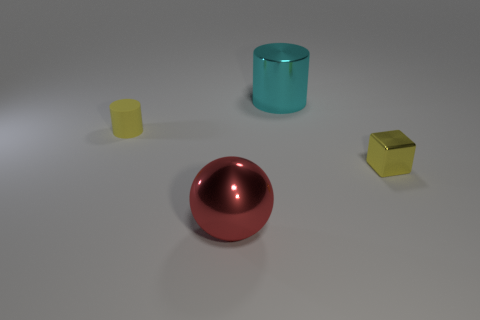Add 1 cyan cylinders. How many objects exist? 5 Subtract all spheres. How many objects are left? 3 Subtract all green rubber cubes. Subtract all metallic objects. How many objects are left? 1 Add 3 large cylinders. How many large cylinders are left? 4 Add 3 small gray rubber cubes. How many small gray rubber cubes exist? 3 Subtract 0 purple balls. How many objects are left? 4 